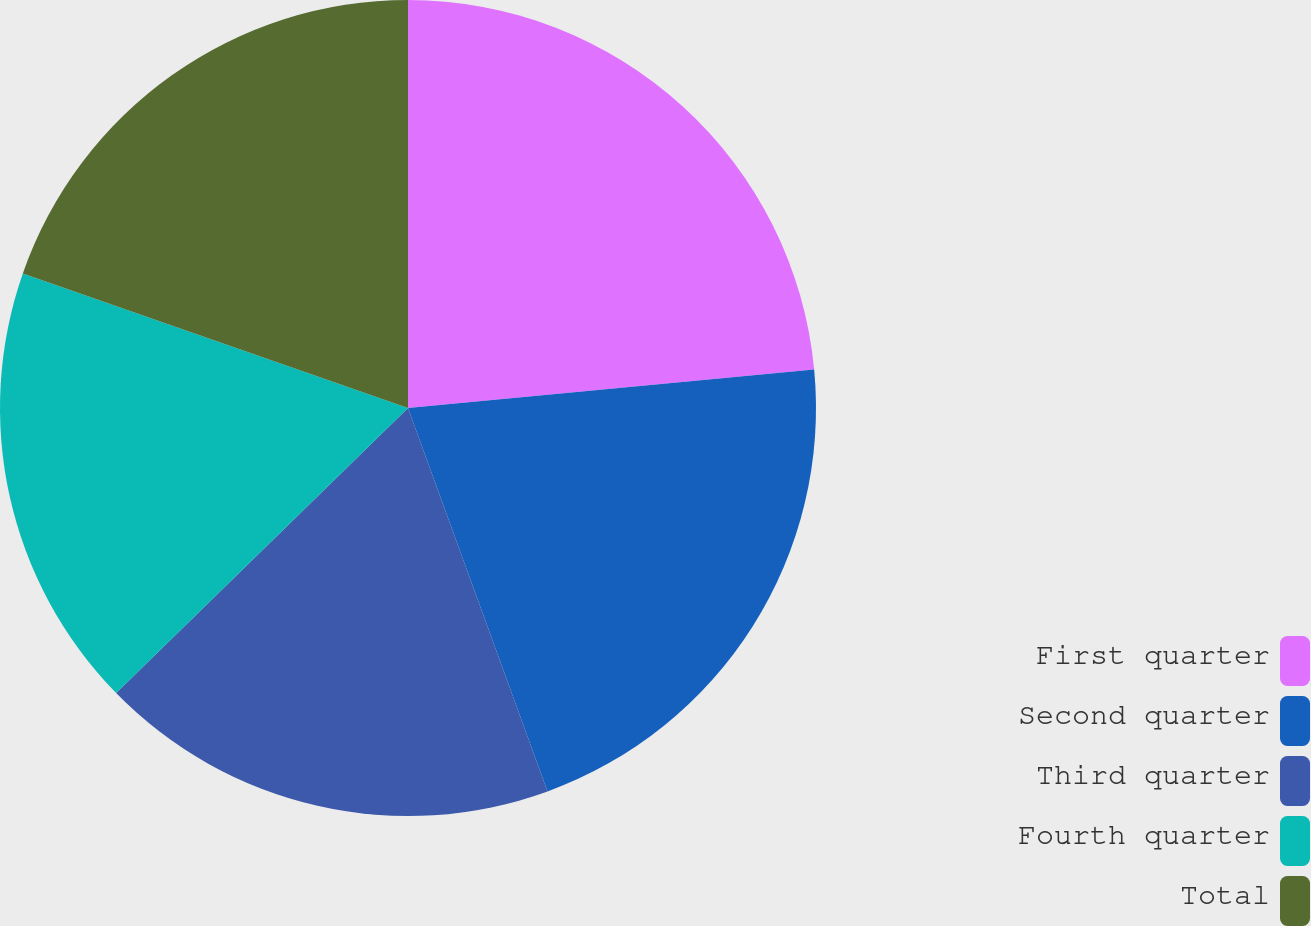Convert chart to OTSL. <chart><loc_0><loc_0><loc_500><loc_500><pie_chart><fcel>First quarter<fcel>Second quarter<fcel>Third quarter<fcel>Fourth quarter<fcel>Total<nl><fcel>23.49%<fcel>20.95%<fcel>18.24%<fcel>17.66%<fcel>19.65%<nl></chart> 